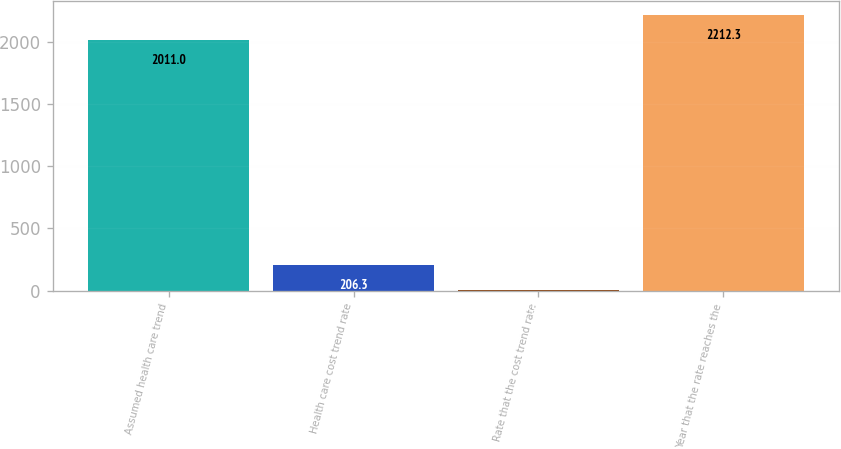Convert chart. <chart><loc_0><loc_0><loc_500><loc_500><bar_chart><fcel>Assumed health care trend<fcel>Health care cost trend rate<fcel>Rate that the cost trend rate<fcel>Year that the rate reaches the<nl><fcel>2011<fcel>206.3<fcel>5<fcel>2212.3<nl></chart> 